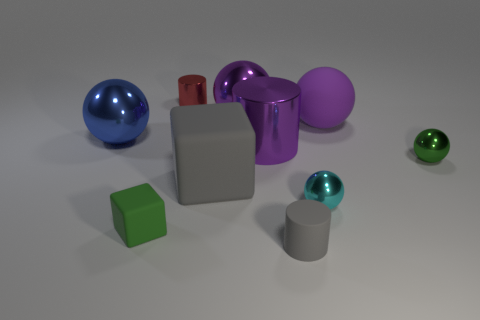Subtract all blue spheres. How many spheres are left? 4 Subtract all large matte balls. How many balls are left? 4 Subtract all red balls. Subtract all blue blocks. How many balls are left? 5 Subtract all cylinders. How many objects are left? 7 Subtract all yellow metallic blocks. Subtract all big blue objects. How many objects are left? 9 Add 6 small cyan balls. How many small cyan balls are left? 7 Add 2 red things. How many red things exist? 3 Subtract 0 purple cubes. How many objects are left? 10 